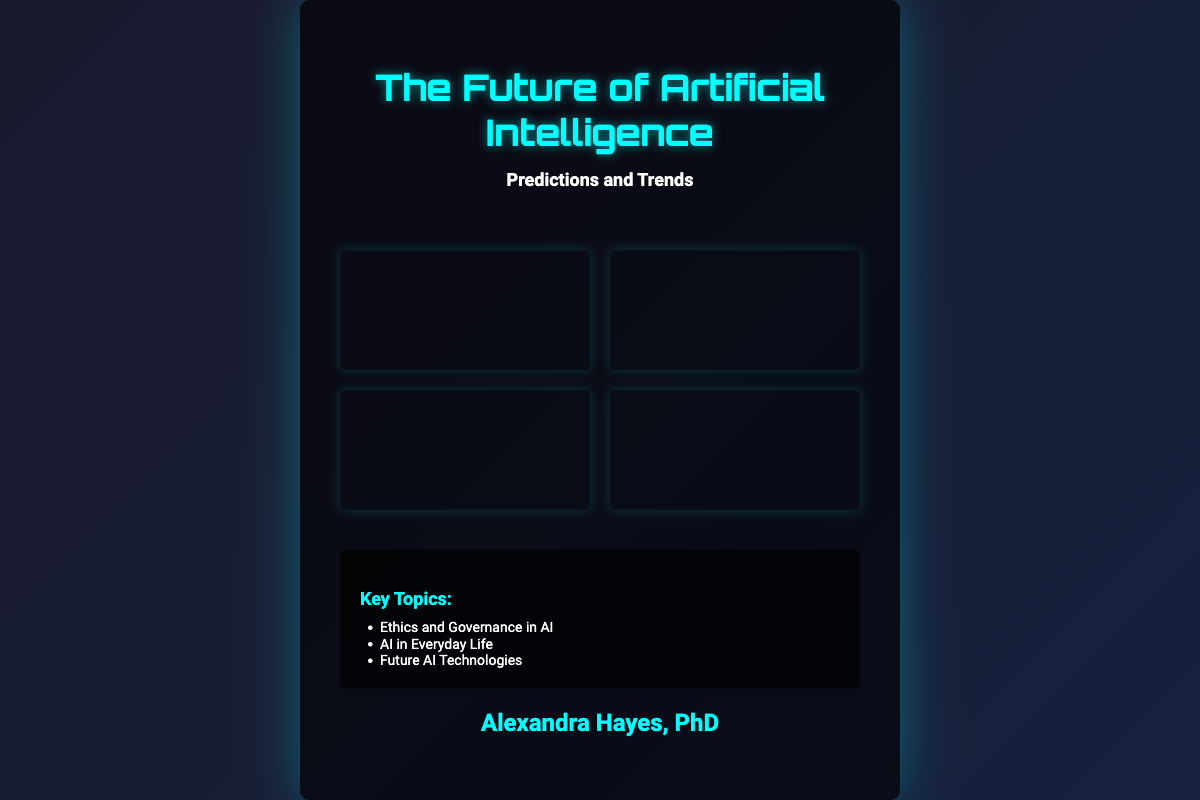What is the title of the book? The title can be found prominently displayed at the top of the cover.
Answer: The Future of Artificial Intelligence Who is the author of the book? The author’s name is mentioned at the bottom of the cover.
Answer: Alexandra Hayes, PhD What are the two main sections of the cover? The cover contains distinct sections for the title and the key topics, among others.
Answer: Title and Key Topics What is one key topic listed on the cover? The key topics are presented in a bulleted list within a specific section of the cover.
Answer: Ethics and Governance in AI How many images are displayed on the cover? The cover features a grid layout with several visual elements present.
Answer: Four images What color is used for the title text? The cover design includes specific color choices for the text elements.
Answer: Cyan What is the subtitle of the book? The subtitle is located directly beneath the main title for clarity.
Answer: Predictions and Trends What type of imagery is used on the cover? The cover design incorporates futuristic imagery relevant to the book's subject.
Answer: Futuristic cityscape What is one theme explored in the key topics? The key topics are explicitly listed and related to the book’s subject matter.
Answer: AI in Everyday Life 